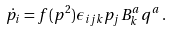<formula> <loc_0><loc_0><loc_500><loc_500>\dot { p } _ { i } = f ( p ^ { 2 } ) \epsilon _ { i j k } p _ { j } B _ { k } ^ { a } q ^ { a } \, .</formula> 